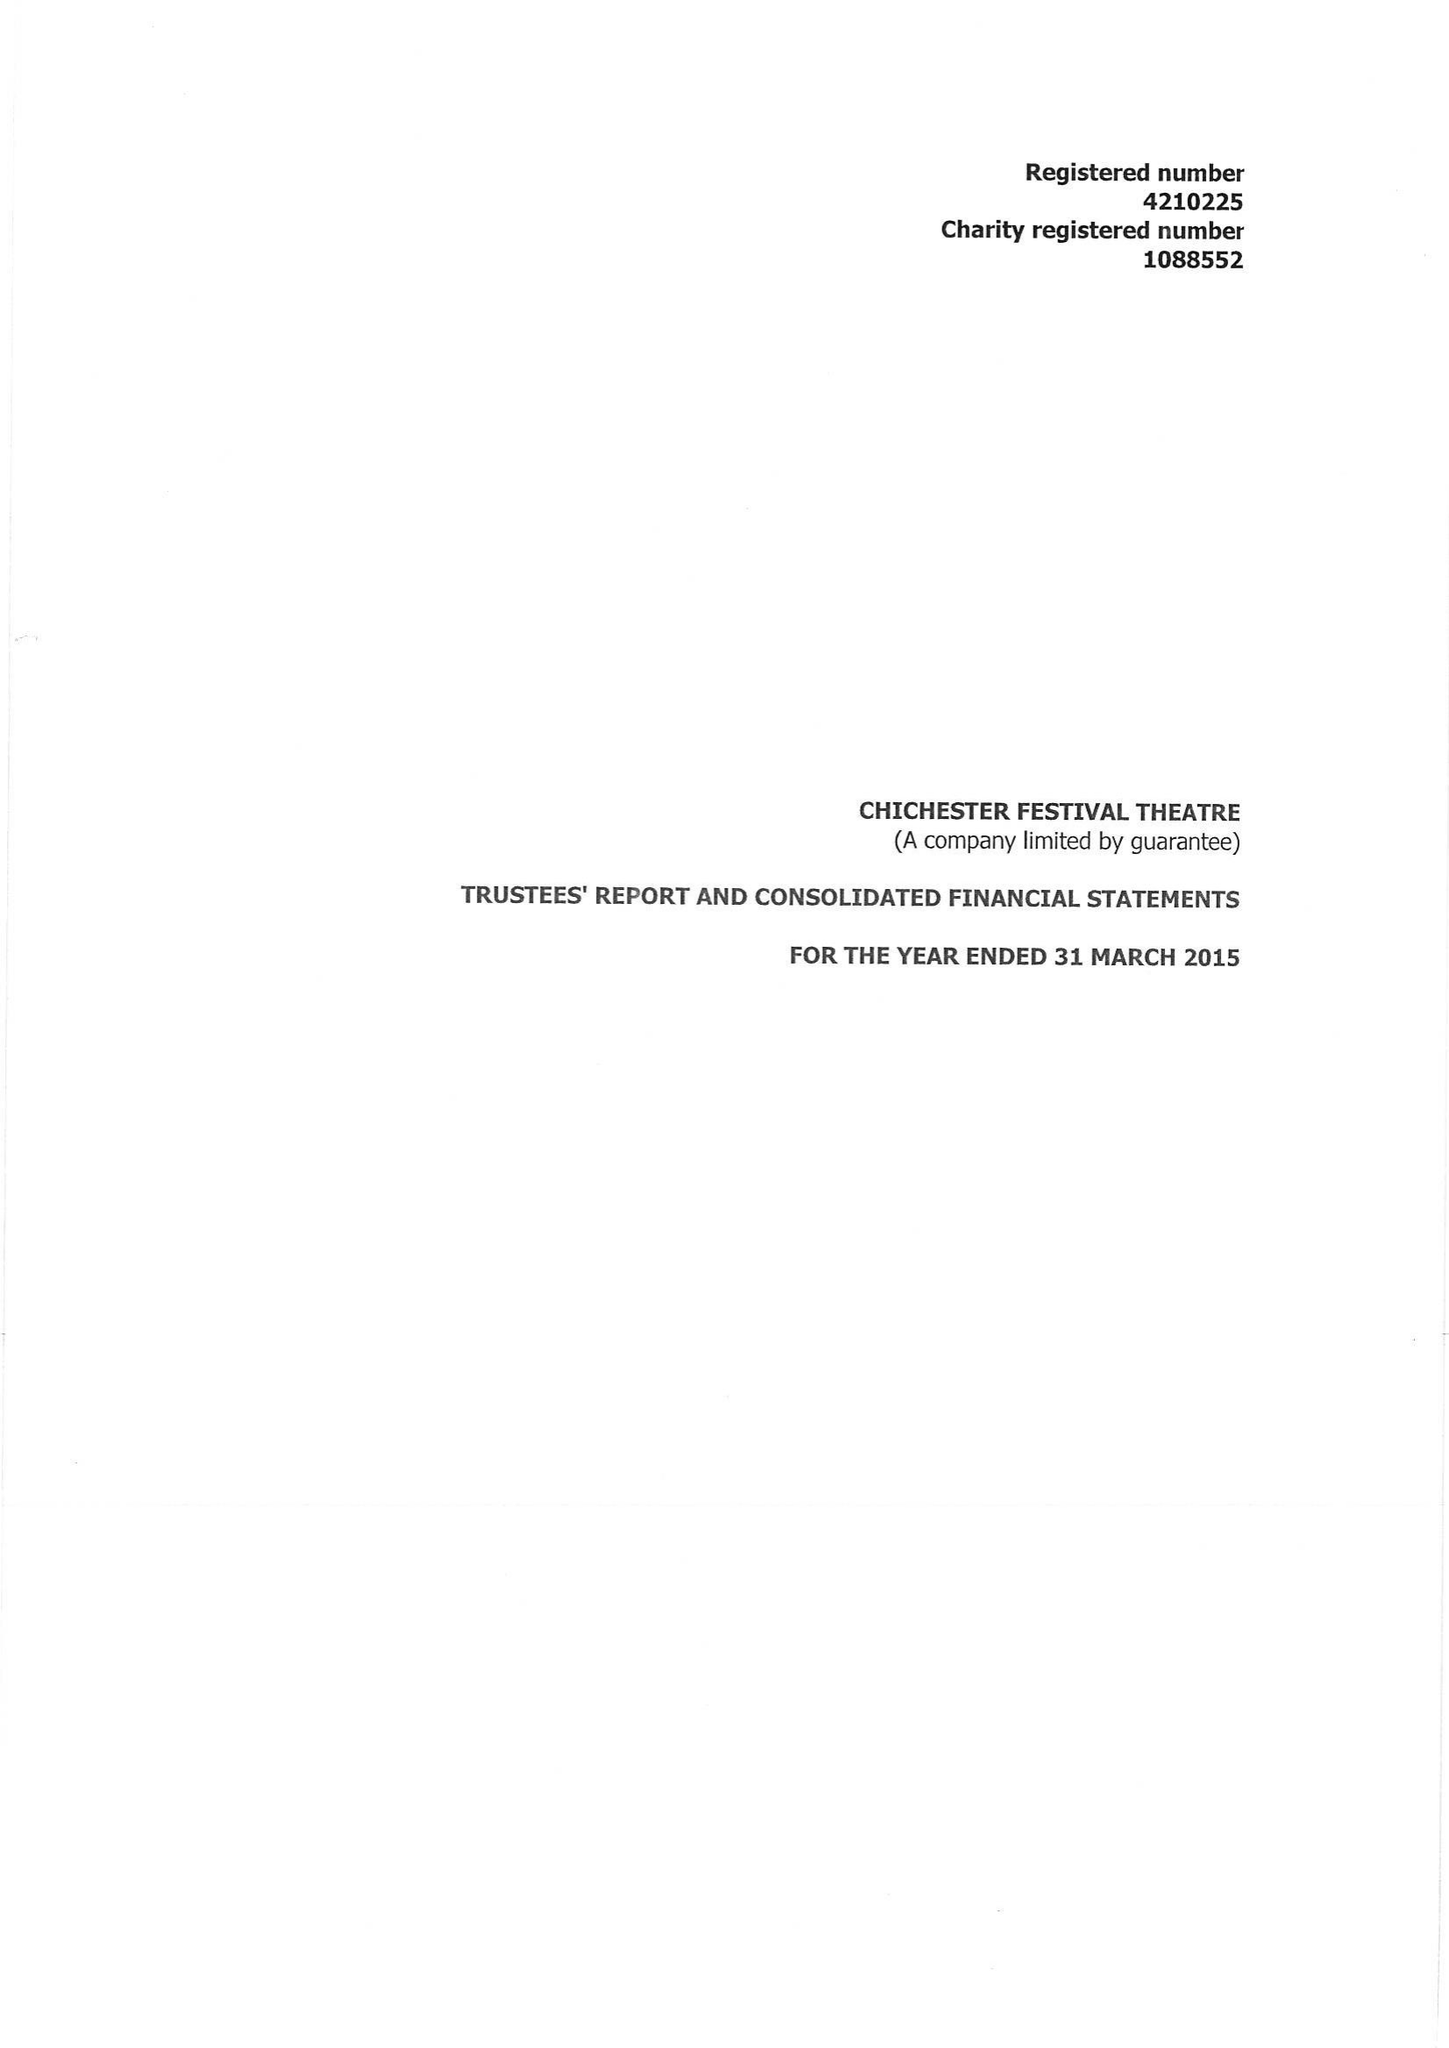What is the value for the income_annually_in_british_pounds?
Answer the question using a single word or phrase. 17017524.00 